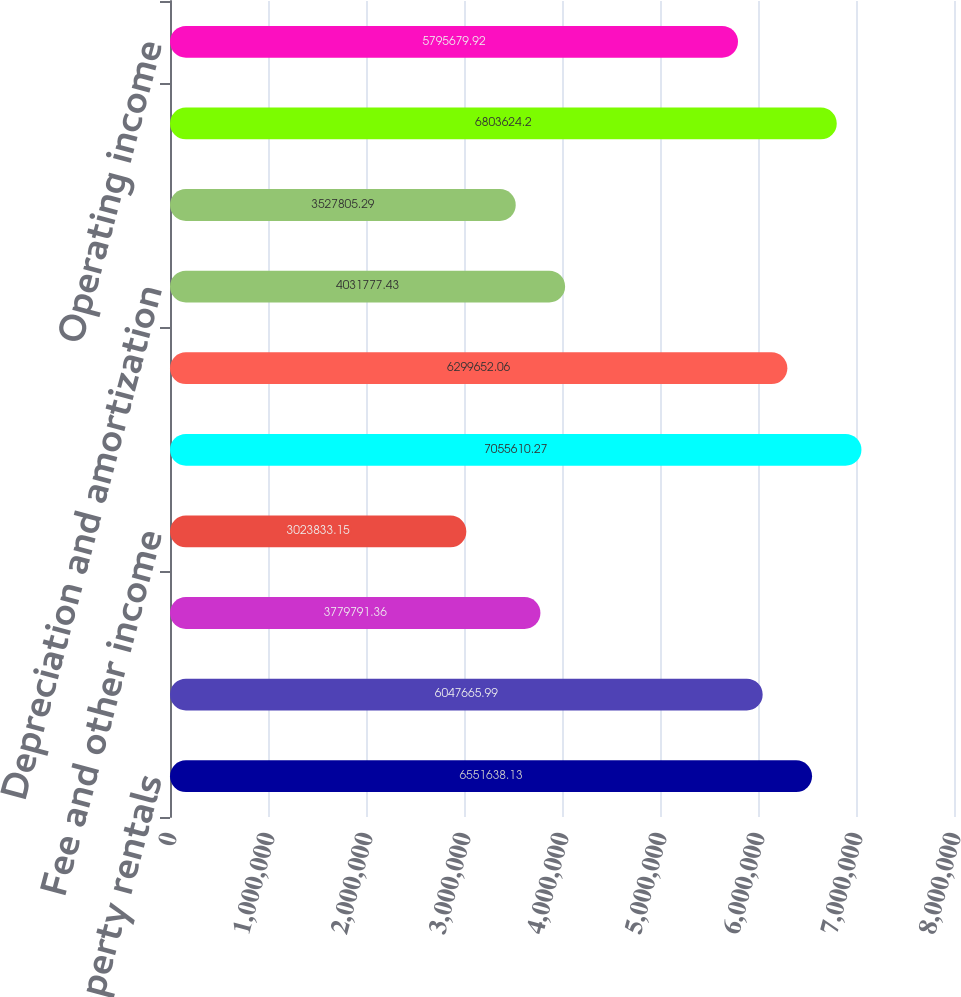Convert chart. <chart><loc_0><loc_0><loc_500><loc_500><bar_chart><fcel>Property rentals<fcel>Temperature Controlled<fcel>Tenant expense reimbursements<fcel>Fee and other income<fcel>Total revenues<fcel>Operating<fcel>Depreciation and amortization<fcel>General and administrative<fcel>Total expenses<fcel>Operating income<nl><fcel>6.55164e+06<fcel>6.04767e+06<fcel>3.77979e+06<fcel>3.02383e+06<fcel>7.05561e+06<fcel>6.29965e+06<fcel>4.03178e+06<fcel>3.52781e+06<fcel>6.80362e+06<fcel>5.79568e+06<nl></chart> 